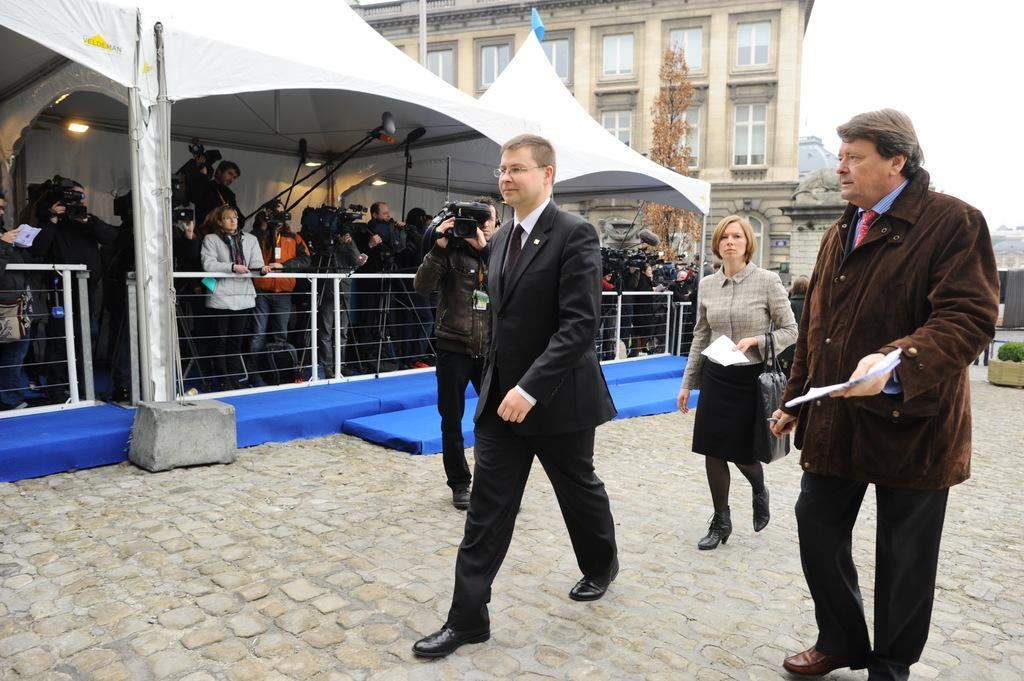What can be observed about the people in the image? There are people standing in the image, and some of them are holding objects. What structures are present in the image? There is a building and a tent in the image. What additional features can be seen in the image? Railings, lights, a plant, and a tree are visible in the image. Are there any laborers working on the plant in the image? There is no indication of laborers or any work being done on the plant in the image. Can you see a snake slithering through the grass in the image? There is no snake present in the image. 